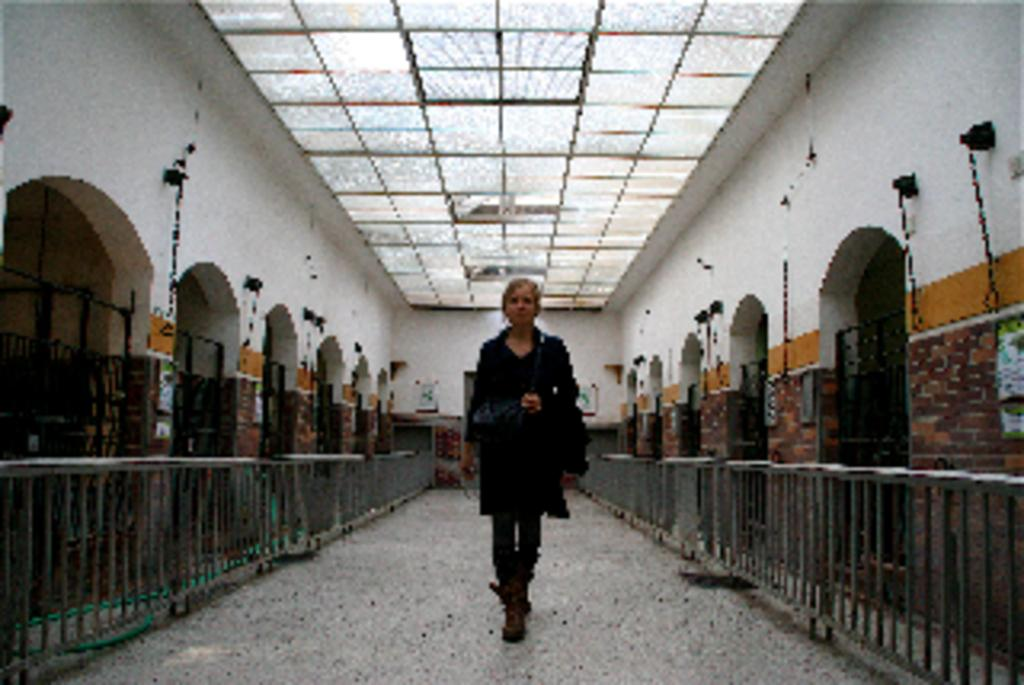What is the main subject of the image? There is a woman standing in the image. Where is the woman located? The woman is inside a building. What can be seen in the background of the image? There is fencing visible in the image. What is on the roof of the building in the image? There are lights on the roof in the image. What is the woman's reaction to the skate in the image? There is no skate present in the image, so the woman's reaction cannot be determined. 